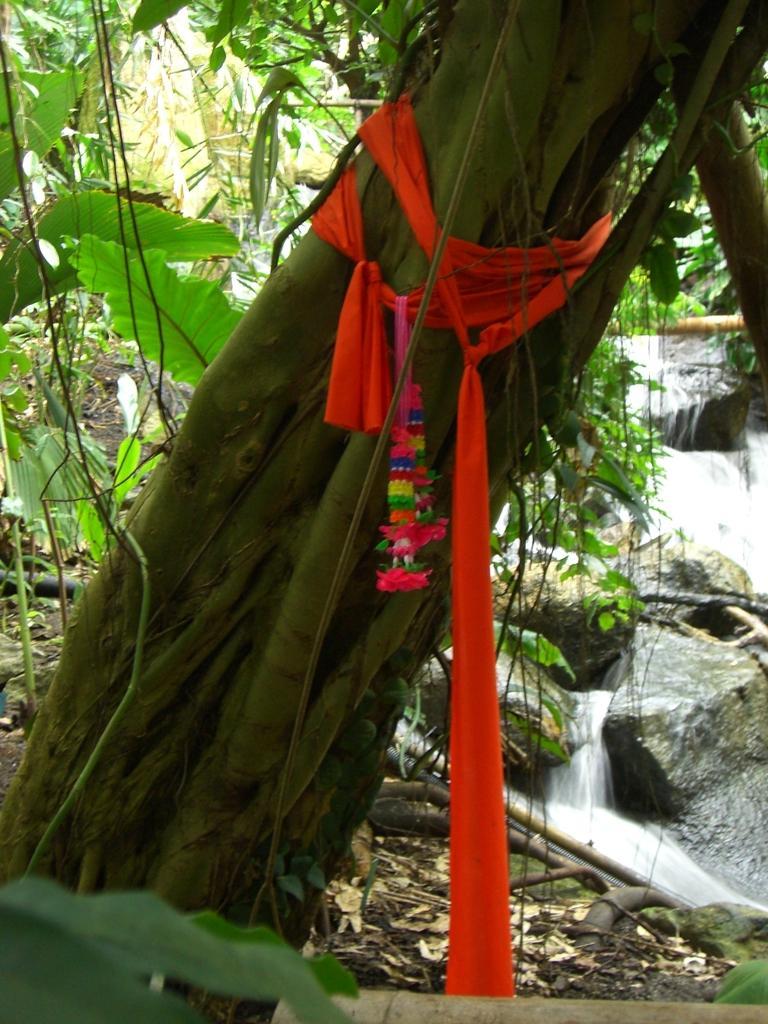How would you summarize this image in a sentence or two? In this image, we can see tree trunk is tied with clothes. In the background, we can see plants, rocks, waterfalls, pipe and dry leaves. 